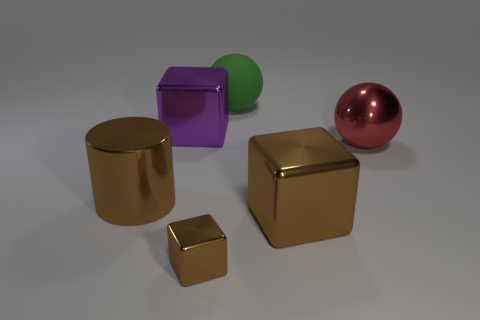Subtract all brown cubes. How many cubes are left? 1 Add 2 big purple things. How many objects exist? 8 Subtract all yellow cylinders. How many brown cubes are left? 2 Subtract all balls. How many objects are left? 4 Add 5 shiny cylinders. How many shiny cylinders exist? 6 Subtract all purple cubes. How many cubes are left? 2 Subtract 0 cyan cylinders. How many objects are left? 6 Subtract 1 blocks. How many blocks are left? 2 Subtract all purple blocks. Subtract all blue cylinders. How many blocks are left? 2 Subtract all big yellow matte cylinders. Subtract all big green rubber balls. How many objects are left? 5 